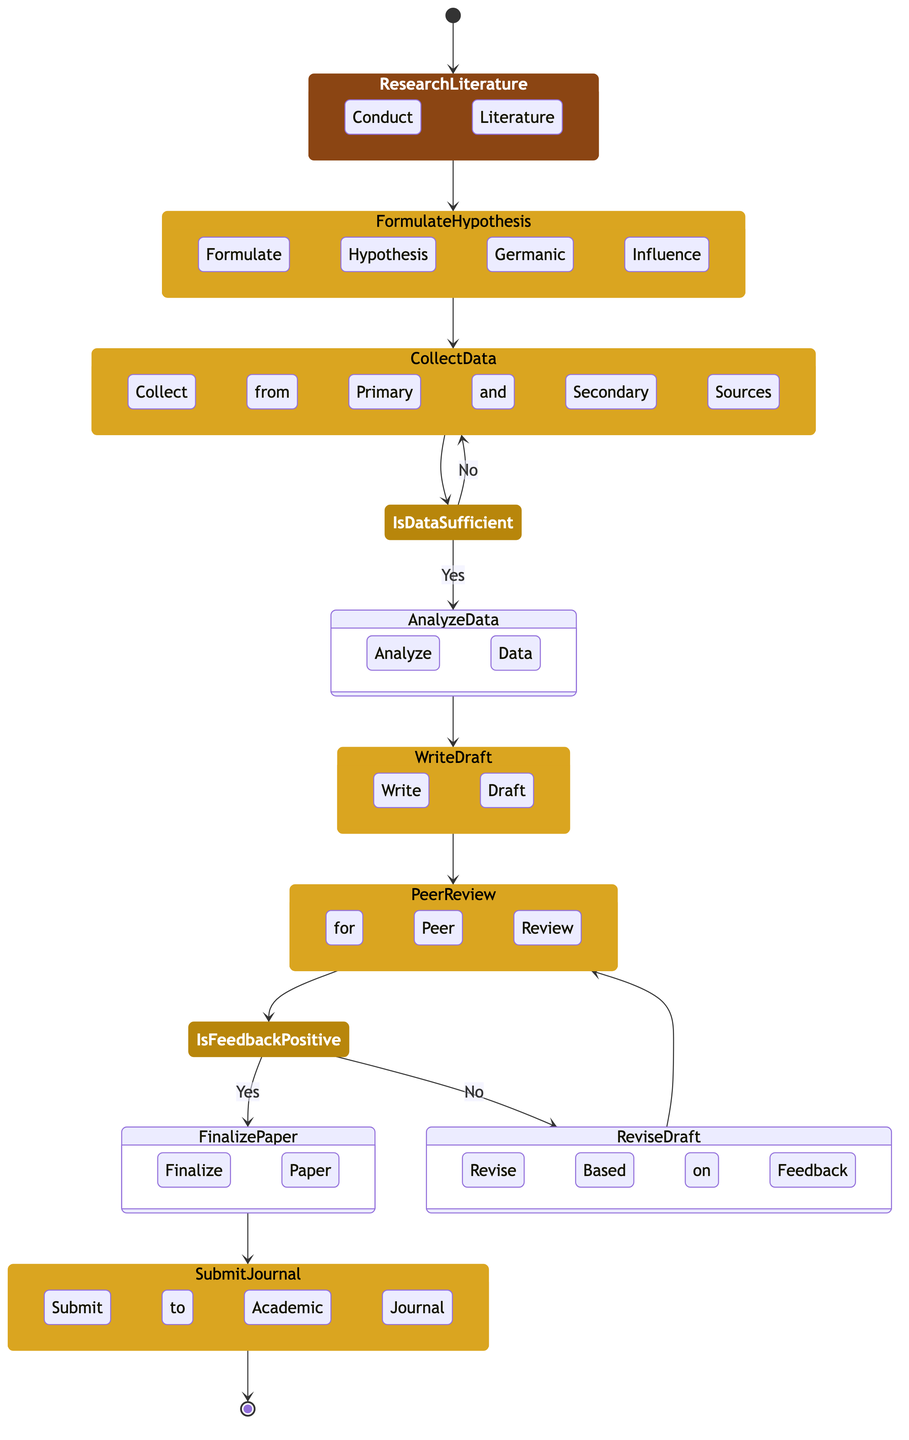What is the first activity in the research paper process? The first activity in the research paper process is represented by the arrow leading from the start event to the first activity node. According to the diagram, this activity is "Conduct Literature Review".
Answer: Conduct Literature Review How many activities are there in total? By counting all the activity nodes in the diagram, we identify six distinct activities: "Conduct Literature Review", "Formulate Hypothesis on Germanic Influence", "Collect Data from Primary and Secondary Sources", "Analyze Data", "Write Draft Paper", and "Finalize Paper".
Answer: Six What is the decision point after collecting data? The decision point immediately following the "Collect Data from Primary and Secondary Sources" activity checks if the data is sufficient. This is articulated in the gateway labeled "Is Data Sufficient?".
Answer: Is Data Sufficient? If the data is insufficient, which activity is revisited? If the condition "No" from the gateway "Is Data Sufficient?" is valid, the process returns to the "Collect Data from Primary and Secondary Sources" activity, indicating that more data needs to be gathered before proceeding.
Answer: Collect Data from Primary and Secondary Sources After receiving positive feedback from peer review, what is the next step? Following a positive outcome from the "Is Peer Review Feedback Positive?" decision point, the process flows to the "Finalize Paper" activity.
Answer: Finalize Paper What happens if the peer review feedback is negative? If the feedback is found to be negative in the "Is Peer Review Feedback Positive?" gateway, the process leads to the "Revise Paper Based on Feedback" activity, indicating that the paper must be revised before resubmitting it for review.
Answer: Revise Paper Based on Feedback How many gateways are present in the diagram? The diagram contains two gateways: "Is Data Sufficient?" and "Is Peer Review Feedback Positive?", which determine the flow based on specific conditions.
Answer: Two What is the last activity in the workflow? The last activity in the research paper workflow is to submit the paper to an academic journal, represented by the node "Submit to Academic Journal", which follows the finalization of the paper.
Answer: Submit to Academic Journal 